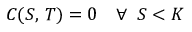<formula> <loc_0><loc_0><loc_500><loc_500>C ( S , \, T ) = 0 \quad \forall \, S < K</formula> 